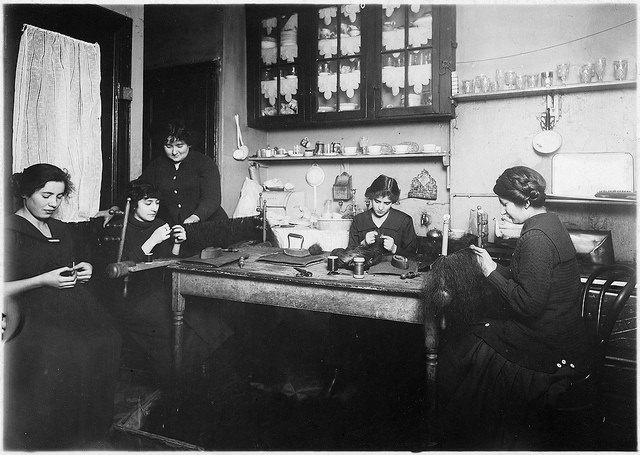Describe the objects in this image and their specific colors. I can see cup in white, black, lightgray, gray, and darkgray tones, people in white, black, gray, lightgray, and darkgray tones, people in white, black, gray, lightgray, and darkgray tones, dining table in white, gray, darkgray, black, and lightgray tones, and chair in white, black, gray, lightgray, and darkgray tones in this image. 